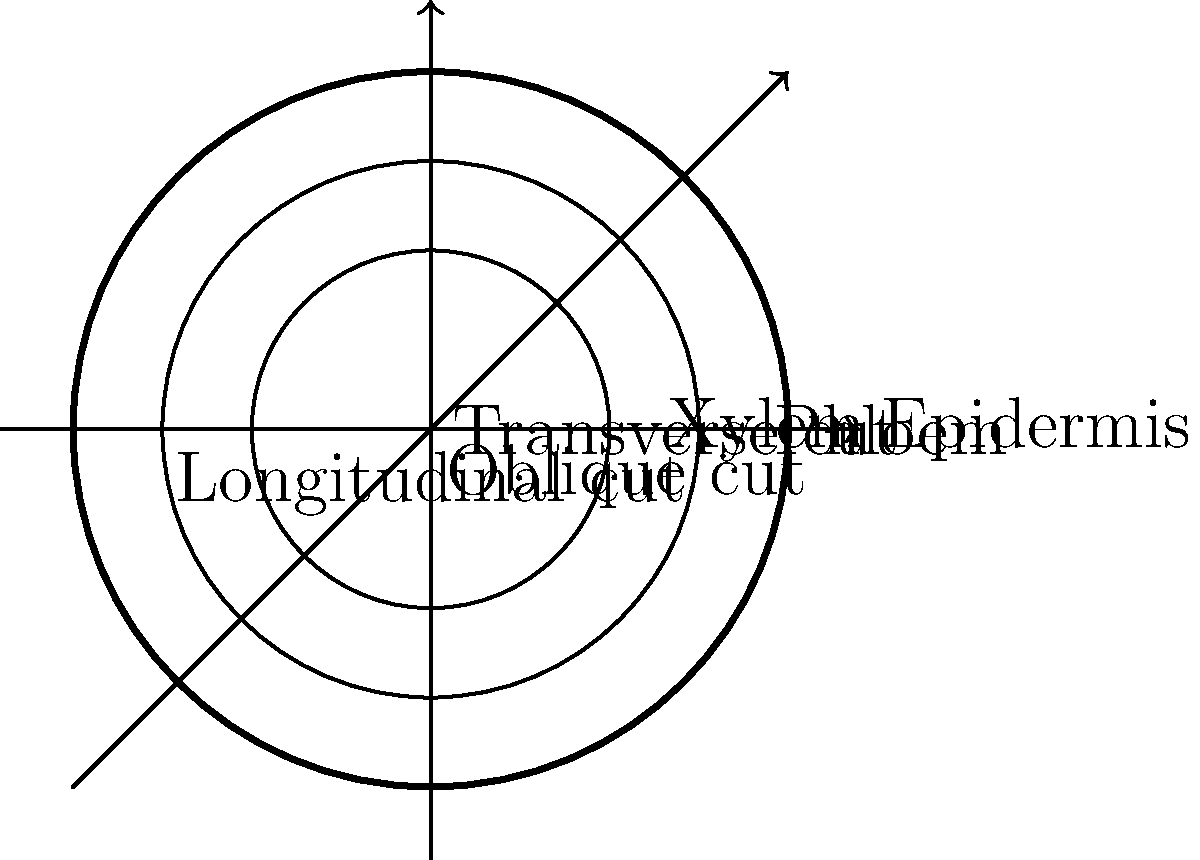Which of the following cross-sections would you expect to see if a plant stem is cut at an oblique angle (neither perfectly transverse nor longitudinal)?

A) A perfect circle
B) An elongated ellipse
C) A series of concentric circles
D) A spiral pattern Let's think about this step-by-step:

1. First, recall the structure of a typical plant stem. It consists of concentric layers: the outermost epidermis, then cortex, vascular bundles (phloem and xylem), and sometimes pith in the center.

2. A transverse (horizontal) cut would show these layers as perfect concentric circles.

3. A longitudinal (vertical) cut would show these layers as parallel lines running along the length of the stem.

4. An oblique cut is at an angle between transverse and longitudinal. To visualize this:

   a) Imagine slicing a cylindrical object (like a cucumber) at an angle.
   b) The resulting face would be oval or elliptical in shape.

5. This elliptical shape occurs because:
   - The circular cross-section is stretched out along one axis.
   - The more oblique the angle, the more elongated the ellipse becomes.

6. The internal structures (xylem, phloem, etc.) would also appear as elongated ellipses within the main elliptical shape.

Therefore, an oblique cut would result in an elongated ellipse, not a perfect circle, concentric circles, or a spiral pattern.
Answer: B) An elongated ellipse 